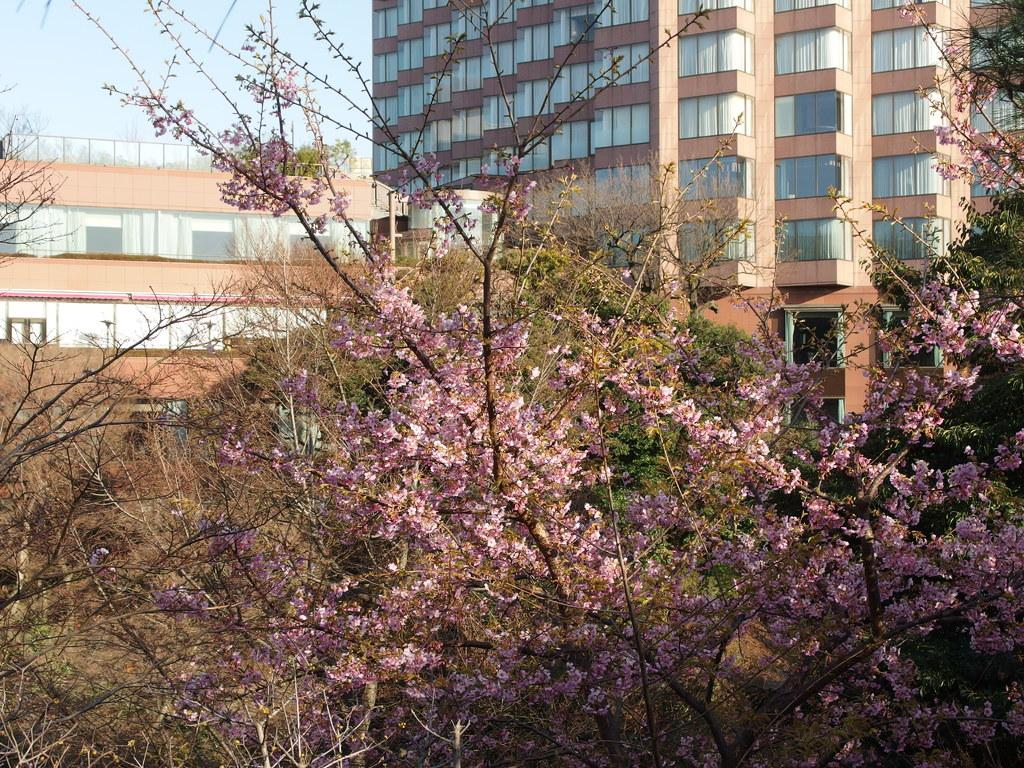What type of vegetation can be seen in the image? There are trees in the image. Can you describe a specific tree in the image? There is a tree with pink flowers in the image. What can be seen in the distance behind the trees? There are buildings in the background of the image. What is visible in the sky in the image? The sky is visible in the background of the image. What team is playing a story in the image? There is no team or story present in the image; it features trees, a tree with pink flowers, buildings in the background, and the sky. How many times does the person jump in the image? There is no person or jumping activity depicted in the image. 